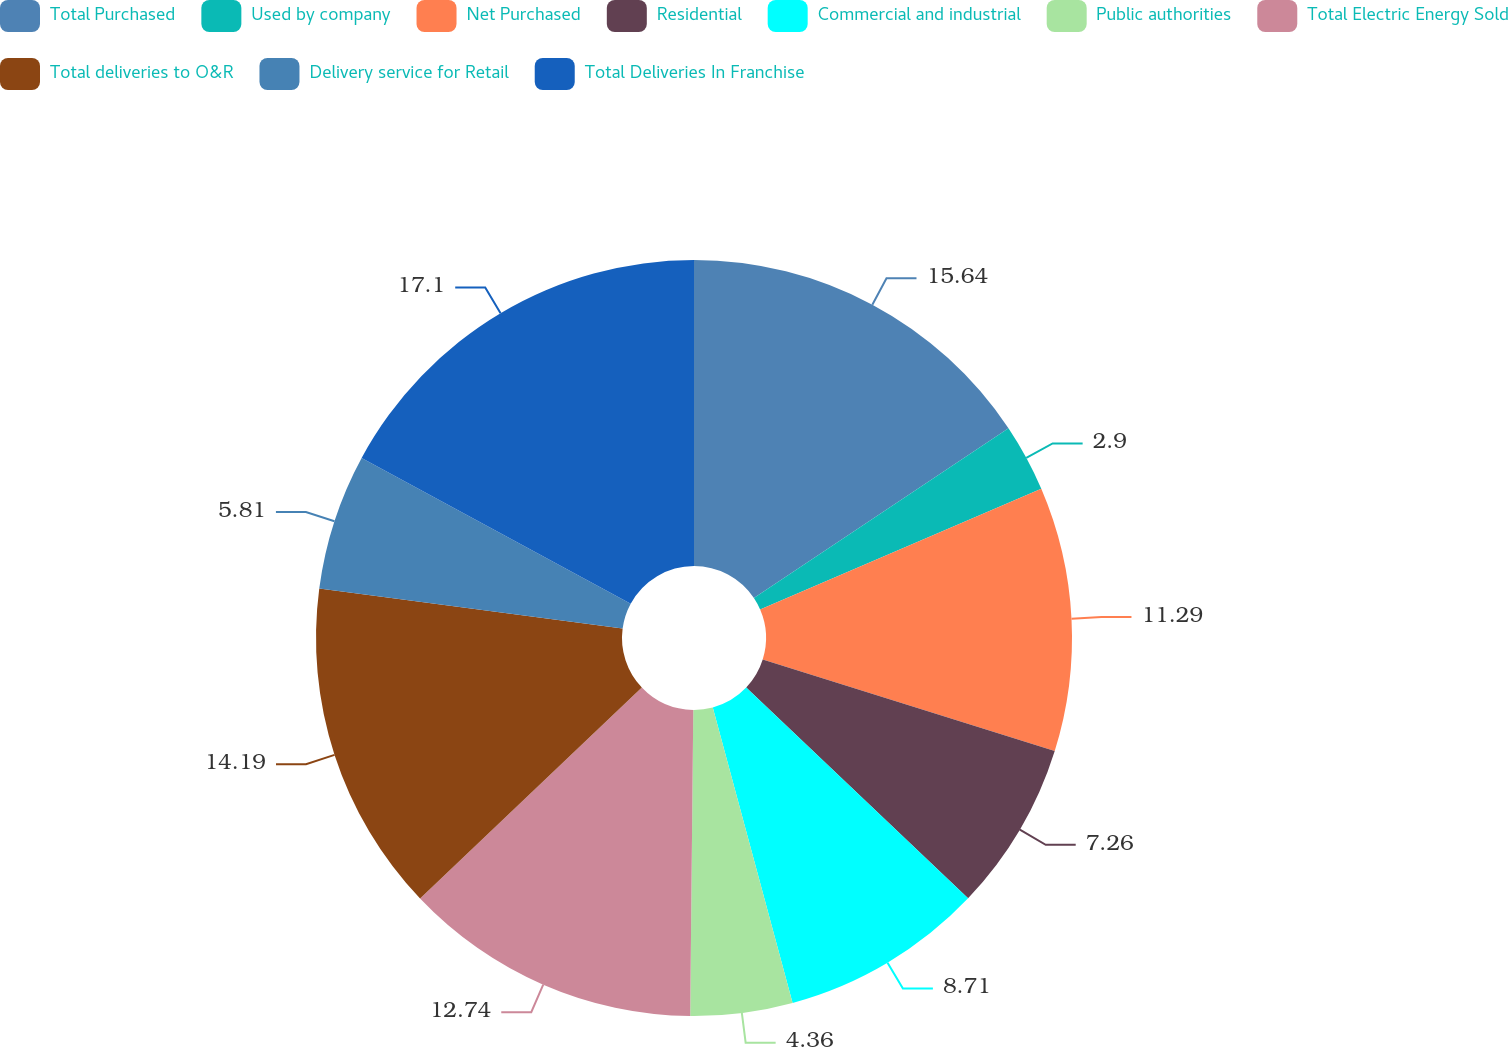Convert chart to OTSL. <chart><loc_0><loc_0><loc_500><loc_500><pie_chart><fcel>Total Purchased<fcel>Used by company<fcel>Net Purchased<fcel>Residential<fcel>Commercial and industrial<fcel>Public authorities<fcel>Total Electric Energy Sold<fcel>Total deliveries to O&R<fcel>Delivery service for Retail<fcel>Total Deliveries In Franchise<nl><fcel>15.64%<fcel>2.9%<fcel>11.29%<fcel>7.26%<fcel>8.71%<fcel>4.36%<fcel>12.74%<fcel>14.19%<fcel>5.81%<fcel>17.1%<nl></chart> 